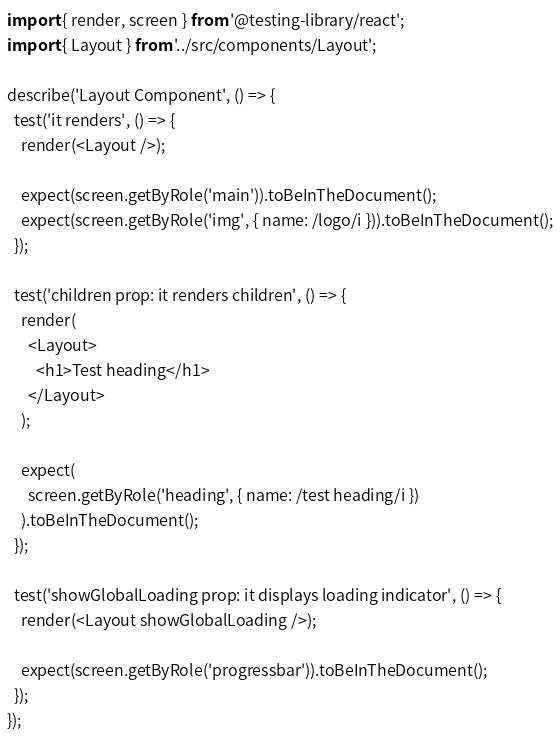<code> <loc_0><loc_0><loc_500><loc_500><_TypeScript_>import { render, screen } from '@testing-library/react';
import { Layout } from '../src/components/Layout';

describe('Layout Component', () => {
  test('it renders', () => {
    render(<Layout />);

    expect(screen.getByRole('main')).toBeInTheDocument();
    expect(screen.getByRole('img', { name: /logo/i })).toBeInTheDocument();
  });

  test('children prop: it renders children', () => {
    render(
      <Layout>
        <h1>Test heading</h1>
      </Layout>
    );

    expect(
      screen.getByRole('heading', { name: /test heading/i })
    ).toBeInTheDocument();
  });

  test('showGlobalLoading prop: it displays loading indicator', () => {
    render(<Layout showGlobalLoading />);

    expect(screen.getByRole('progressbar')).toBeInTheDocument();
  });
});
</code> 